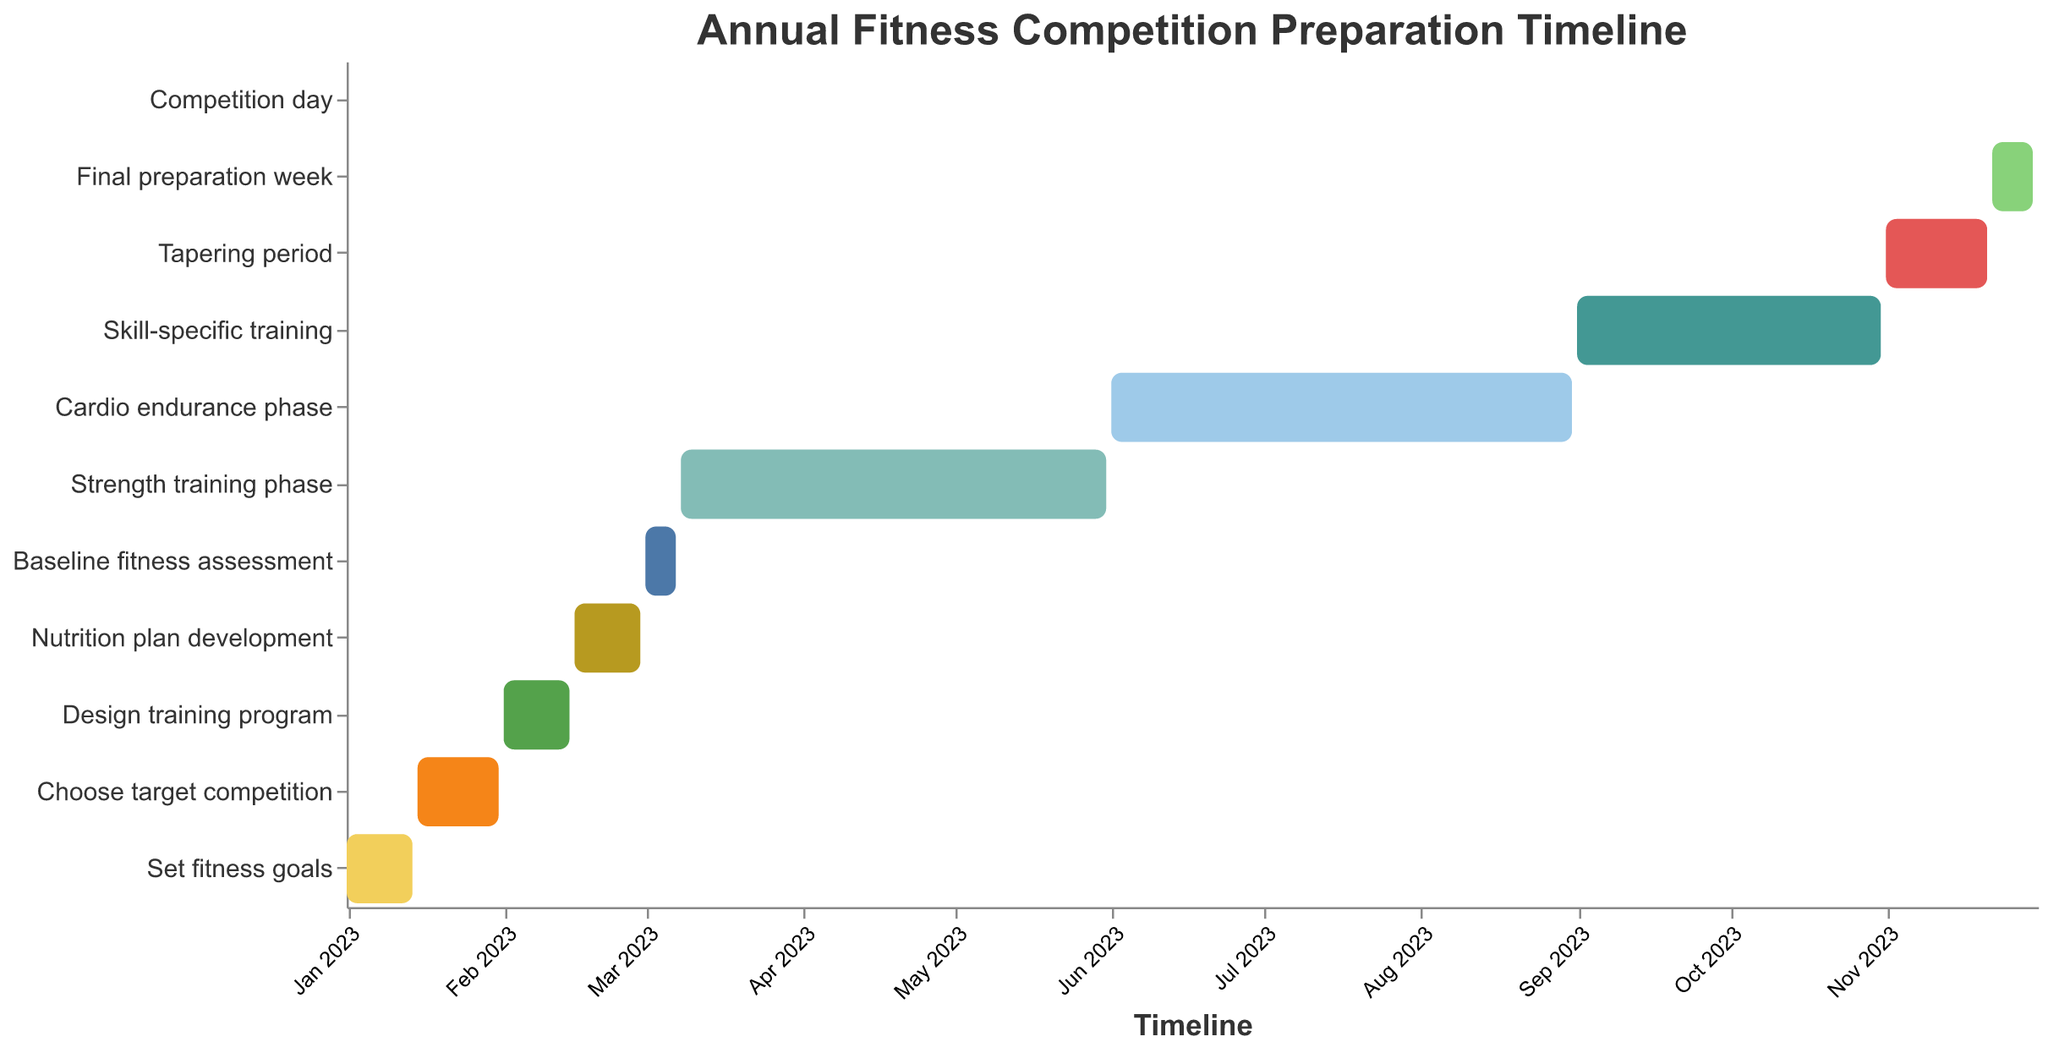What's the title of the chart? The title is usually located at the top of the chart and is written in a larger font size compared to other text. The chart has a title specified as "Annual Fitness Competition Preparation Timeline".
Answer: Annual Fitness Competition Preparation Timeline Which task has the shortest duration? Looking at the lengths of the bars in the Gantt Chart, the task "Competition day" has the shortest duration covering only a single day, from 2023-12-01 to 2023-12-01.
Answer: Competition day Which phases overlap with the "Cardio endurance phase"? Based on the visualization of the timeline, “Cardio endurance phase” runs from 2023-06-01 to 2023-08-31. The task right before and after this phase are “Strength training phase” and “Skill-specific training”, which overlap as the former ends on 2023-05-31 and the latter begins on 2023-09-01. There is no actual overlap with "Cardio endurance phase" itself.
Answer: No overlapping phases What is the duration of the "Strength training phase"? By subtracting the start date from the end date of the "Strength training phase", which spans from 2023-03-08 to 2023-05-31: Calculate the number of days between the two dates.
Answer: 85 days Which task immediately follows the "Design training program"? In the timeline, "Design training program" ends on 2023-02-14 and the next task starting from 2023-02-15 is "Nutrition plan development".
Answer: Nutrition plan development How many tasks are scheduled for less than a month? By examining the lengths of each task bar in the chart, the tasks that last less than a month are: "Set fitness goals", "Choose target competition", "Design training program", "Nutrition plan development", "Baseline fitness assessment", "Tapering period", and "Final preparation week". Count each occurrence.
Answer: 7 tasks Which two tasks run simultaneously at different points in the year? Reviewing the chart, look for tasks that have overlapping dates. "Strength training phase" and "Baseline fitness assessment" overlap as the assessment is within the larger strength training phase from 2023-03-01 to 2023-03-08.
Answer: Strength training phase and Baseline fitness assessment What are the major phases leading up to the competition day? Analyzing the concept of the chart, the major phases can be readily picked out by observing longer periods and key transitions:
1) Strength training phase: 2023-03-08 to 2023-05-31
2) Cardio endurance phase: 2023-06-01 to 2023-08-31
3) Skill-specific training: 2023-09-01 to 2023-10-31
4) Tapering period: 2023-11-01 to 2023-11-21
5) Final preparation week: 2023-11-22 to 2023-11-30. 
These lead up to the "Competition day".
Answer: Strength training, Cardio endurance, Skill-specific training, Tapering, Final preparation How long is the entire preparation period, from the first task to the competition day? The preparation starts with "Set fitness goals" on 2023-01-01 and ends with "Competition day" on 2023-12-01. Counting the days between these two points gives the total duration. Calculate the number of days between January 1 and December 1.
Answer: 335 days Which task involves nutritional planning? According to the task names and their schedule, the task dedicated to nutritional planning is explicitly named "Nutrition plan development", happening from 2023-02-15 to 2023-02-28.
Answer: Nutrition plan development 